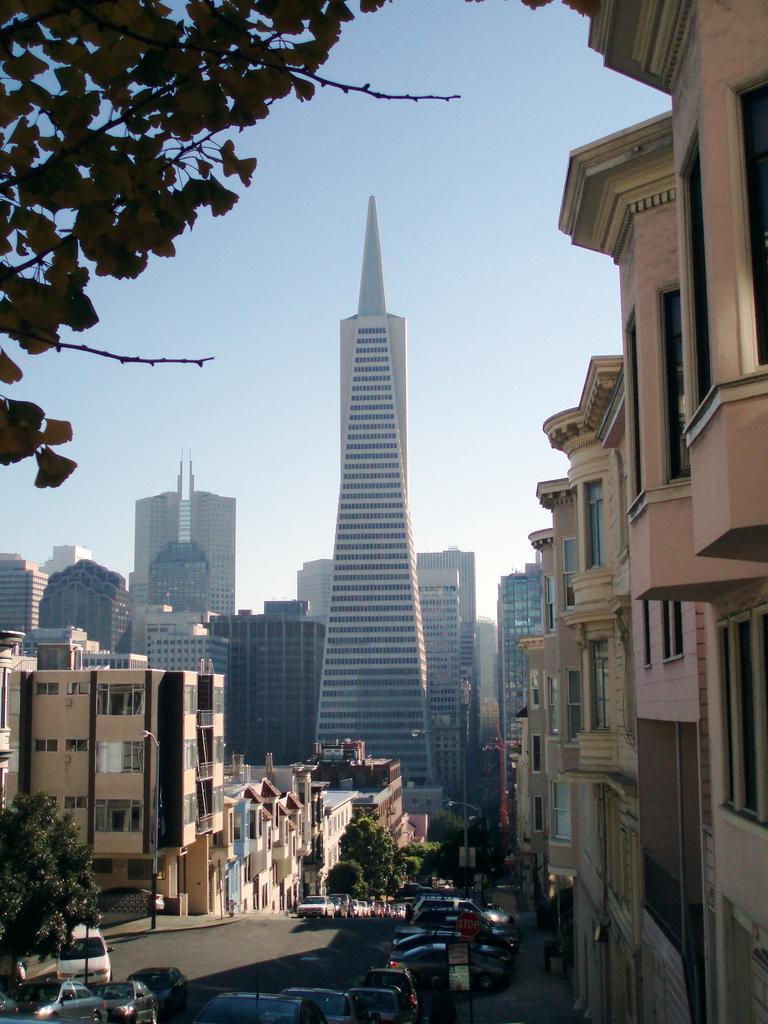Please provide a concise description of this image. In the foreground of the image we can see group of vehicles parked on the ground, sign boards with some text and some poles. In the background, we can see a group of trees, buildings with windows and the sky. 